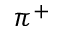<formula> <loc_0><loc_0><loc_500><loc_500>\pi ^ { + }</formula> 